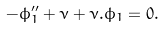Convert formula to latex. <formula><loc_0><loc_0><loc_500><loc_500>- \phi _ { 1 } ^ { \prime \prime } + \nu + \nu . \phi _ { 1 } = 0 .</formula> 